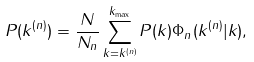Convert formula to latex. <formula><loc_0><loc_0><loc_500><loc_500>P ( k ^ { ( n ) } ) = \frac { N } { N _ { n } } \sum _ { k = k ^ { ( n ) } } ^ { k _ { \max } } P ( k ) \Phi _ { n } ( k ^ { ( n ) } | k ) ,</formula> 